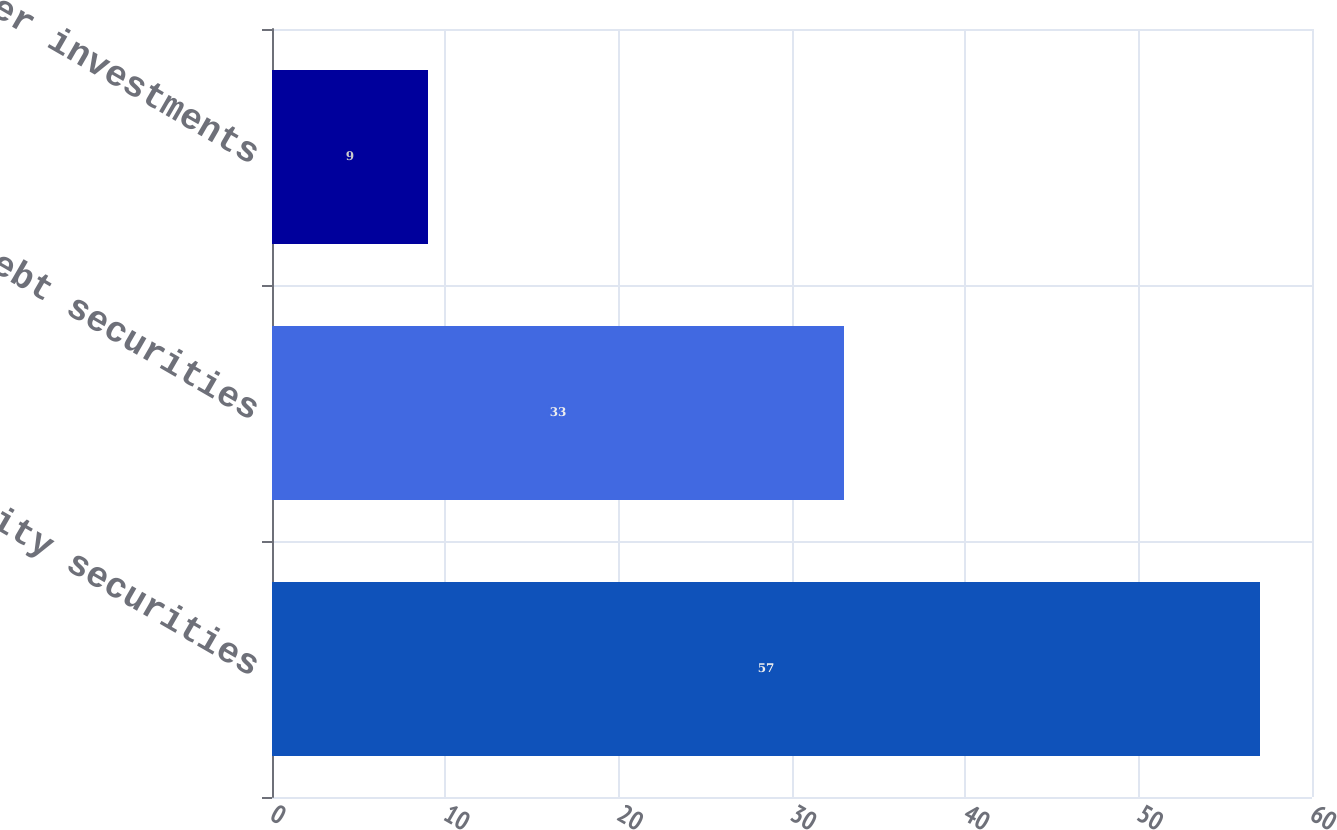<chart> <loc_0><loc_0><loc_500><loc_500><bar_chart><fcel>Equity securities<fcel>Debt securities<fcel>Other investments<nl><fcel>57<fcel>33<fcel>9<nl></chart> 